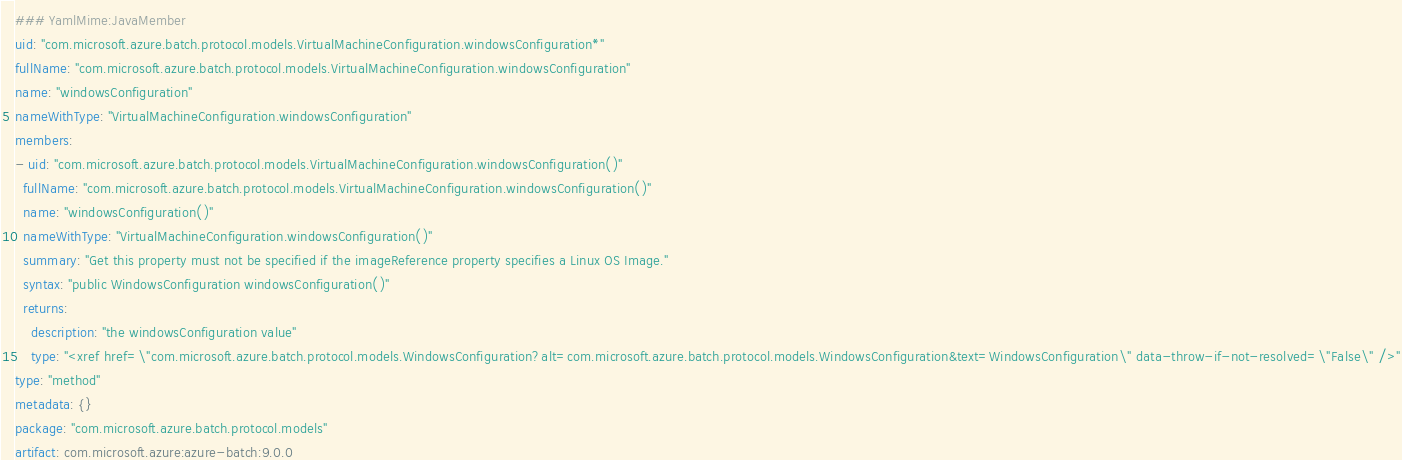<code> <loc_0><loc_0><loc_500><loc_500><_YAML_>### YamlMime:JavaMember
uid: "com.microsoft.azure.batch.protocol.models.VirtualMachineConfiguration.windowsConfiguration*"
fullName: "com.microsoft.azure.batch.protocol.models.VirtualMachineConfiguration.windowsConfiguration"
name: "windowsConfiguration"
nameWithType: "VirtualMachineConfiguration.windowsConfiguration"
members:
- uid: "com.microsoft.azure.batch.protocol.models.VirtualMachineConfiguration.windowsConfiguration()"
  fullName: "com.microsoft.azure.batch.protocol.models.VirtualMachineConfiguration.windowsConfiguration()"
  name: "windowsConfiguration()"
  nameWithType: "VirtualMachineConfiguration.windowsConfiguration()"
  summary: "Get this property must not be specified if the imageReference property specifies a Linux OS Image."
  syntax: "public WindowsConfiguration windowsConfiguration()"
  returns:
    description: "the windowsConfiguration value"
    type: "<xref href=\"com.microsoft.azure.batch.protocol.models.WindowsConfiguration?alt=com.microsoft.azure.batch.protocol.models.WindowsConfiguration&text=WindowsConfiguration\" data-throw-if-not-resolved=\"False\" />"
type: "method"
metadata: {}
package: "com.microsoft.azure.batch.protocol.models"
artifact: com.microsoft.azure:azure-batch:9.0.0
</code> 